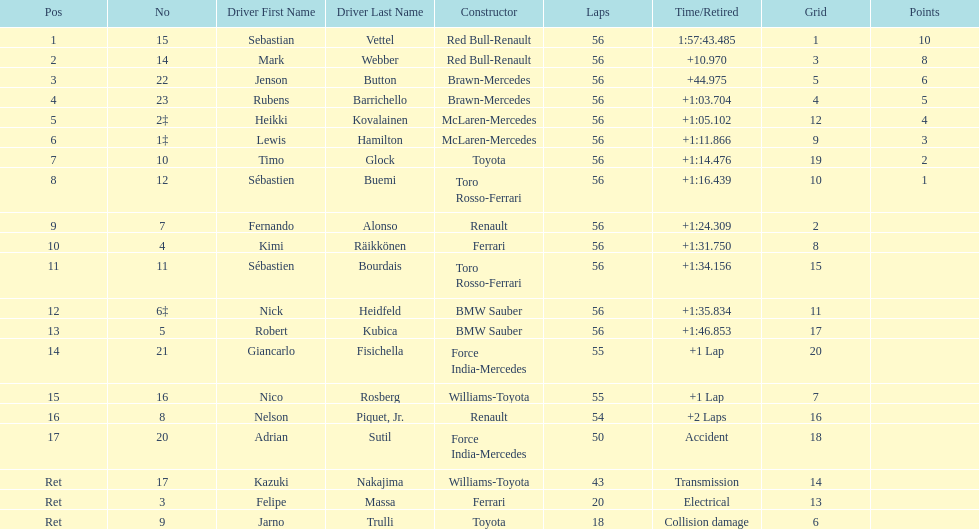What is the name of a driver that ferrari was not a constructor for? Sebastian Vettel. 